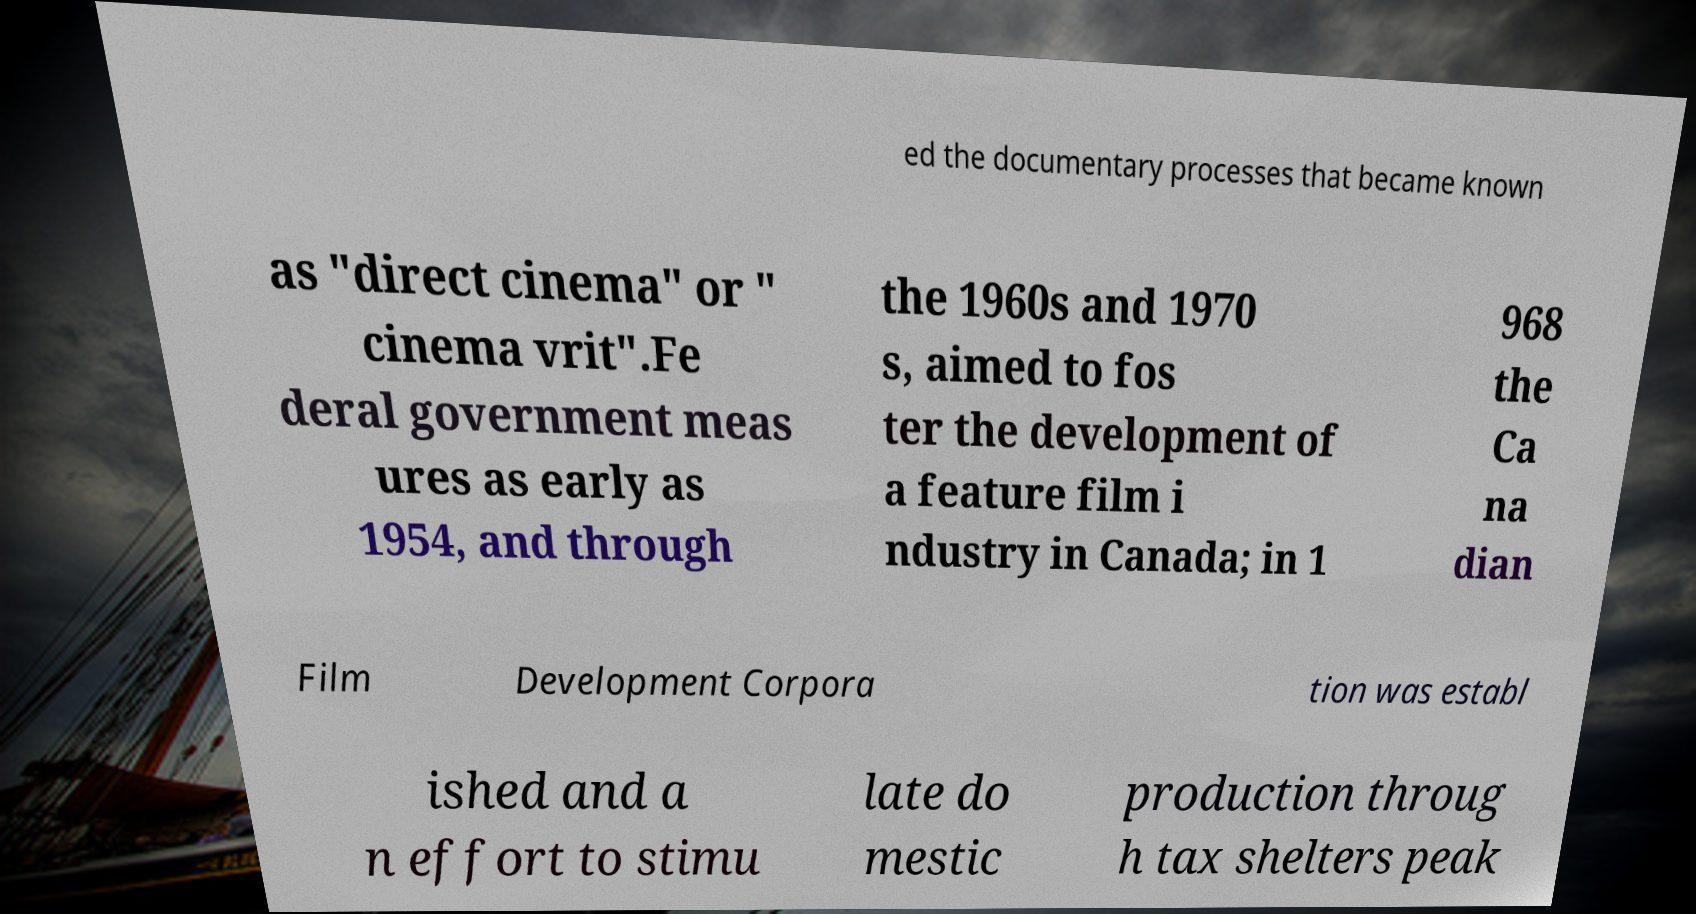Please identify and transcribe the text found in this image. ed the documentary processes that became known as "direct cinema" or " cinema vrit".Fe deral government meas ures as early as 1954, and through the 1960s and 1970 s, aimed to fos ter the development of a feature film i ndustry in Canada; in 1 968 the Ca na dian Film Development Corpora tion was establ ished and a n effort to stimu late do mestic production throug h tax shelters peak 